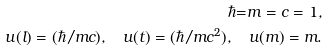Convert formula to latex. <formula><loc_0><loc_0><loc_500><loc_500>\hbar { = } m = c = 1 , \\ u ( l ) = ( \hbar { / } m c ) , \quad u ( t ) = ( \hbar { / } m c ^ { 2 } ) , \quad u ( m ) = m .</formula> 